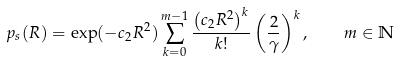Convert formula to latex. <formula><loc_0><loc_0><loc_500><loc_500>p _ { s } ( R ) = \exp ( - c _ { 2 } R ^ { 2 } ) \sum _ { k = 0 } ^ { m - 1 } \frac { \left ( c _ { 2 } R ^ { 2 } \right ) ^ { k } } { k ! } \left ( \frac { 2 } { \gamma } \right ) ^ { k } , \quad m \in \mathbb { N }</formula> 